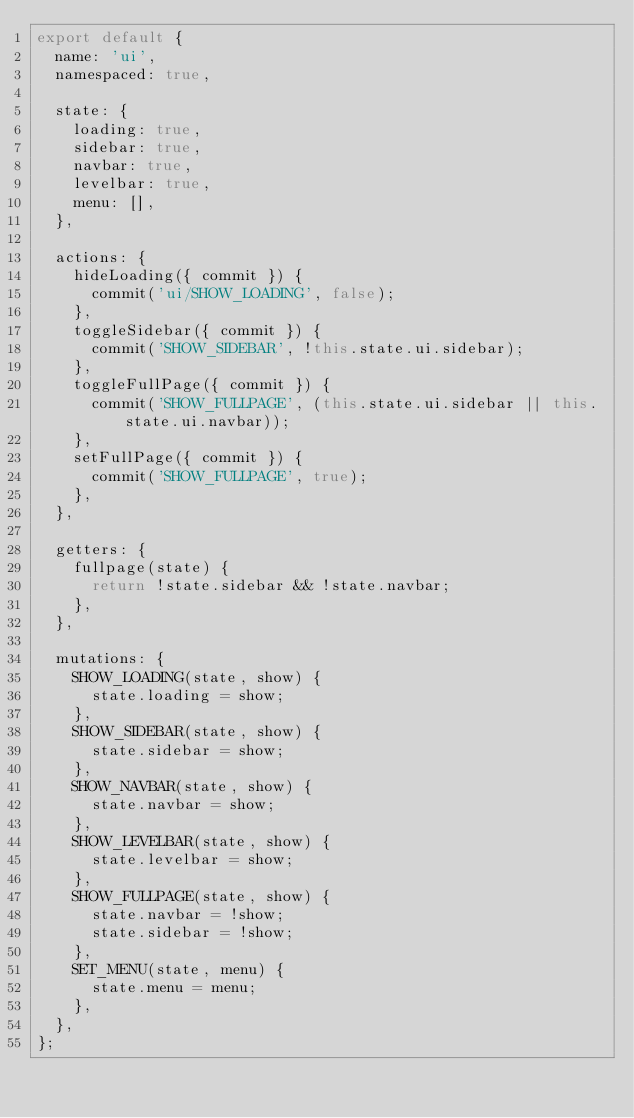<code> <loc_0><loc_0><loc_500><loc_500><_JavaScript_>export default {
  name: 'ui',
  namespaced: true,

  state: {
    loading: true,
    sidebar: true,
    navbar: true,
    levelbar: true,
    menu: [],
  },

  actions: {
    hideLoading({ commit }) {
      commit('ui/SHOW_LOADING', false);
    },
    toggleSidebar({ commit }) {
      commit('SHOW_SIDEBAR', !this.state.ui.sidebar);
    },
    toggleFullPage({ commit }) {
      commit('SHOW_FULLPAGE', (this.state.ui.sidebar || this.state.ui.navbar));
    },
    setFullPage({ commit }) {
      commit('SHOW_FULLPAGE', true);
    },
  },

  getters: {
    fullpage(state) {
      return !state.sidebar && !state.navbar;
    },
  },

  mutations: {
    SHOW_LOADING(state, show) {
      state.loading = show;
    },
    SHOW_SIDEBAR(state, show) {
      state.sidebar = show;
    },
    SHOW_NAVBAR(state, show) {
      state.navbar = show;
    },
    SHOW_LEVELBAR(state, show) {
      state.levelbar = show;
    },
    SHOW_FULLPAGE(state, show) {
      state.navbar = !show;
      state.sidebar = !show;
    },
    SET_MENU(state, menu) {
      state.menu = menu;
    },
  },
};
</code> 